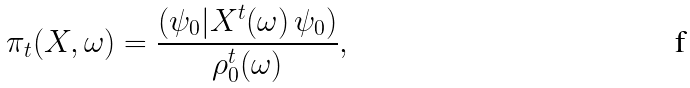<formula> <loc_0><loc_0><loc_500><loc_500>\pi _ { t } ( X , \omega ) = { \frac { ( \psi _ { 0 } | X ^ { t } ( \omega ) \, \psi _ { 0 } ) } { \rho _ { 0 } ^ { t } ( \omega ) } } ,</formula> 